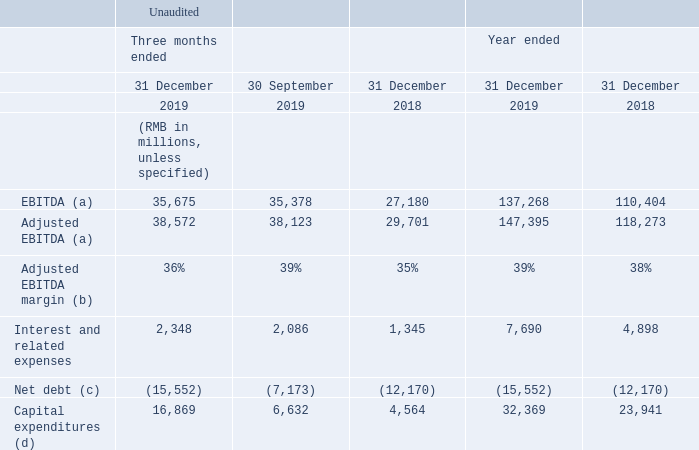(a) EBITDA is calculated as operating profit less interest income and other gains/losses, net and adding back depreciation of property, plant and equipment, investment properties as well as right-of-use assets, and amortisation of intangible assets. Adjusted EBITDA is calculated as EBITDA plus equity-settled share-based compensation expenses.
(b) Adjusted EBITDA margin is calculated by dividing Adjusted EBITDA by revenues.
(c) Net debt represents period end balance and is calculated as cash and cash equivalents, plus term deposits and others, minus borrowings and notes payable.
(d) Capital expenditures consist of additions (excluding business combinations) to property, plant and equipment, construction in progress, investment properties, land use rights and intangible assets (excluding video and music contents, game licences and other contents).
How is the adjusted EBITDA margin calculated? Adjusted ebitda margin is calculated by dividing adjusted ebitda by revenues. What is adjusted EBITDA calculated as? Adjusted ebitda is calculated as ebitda plus equity-settled share-based compensation expenses. What does capital expenditures consist of? Capital expenditures consist of additions (excluding business combinations) to property, plant and equipment, construction in progress, investment properties, land use rights and intangible assets (excluding video and music contents, game licences and other contents). What is the difference between EBITDA and Adjusted EBITDA for three months ended 31 December 2019?
Answer scale should be: million. 38,572-35,675
Answer: 2897. What is the difference between EBITDA and adjusted EBITDA for three months ended 30 September 2019?
Answer scale should be: million. 38,123-35,378
Answer: 2745. What is the difference between EBITDA and adjusted EBITDA for three months ended 31 December 2018?
Answer scale should be: million. 29,701-27,180
Answer: 2521. 